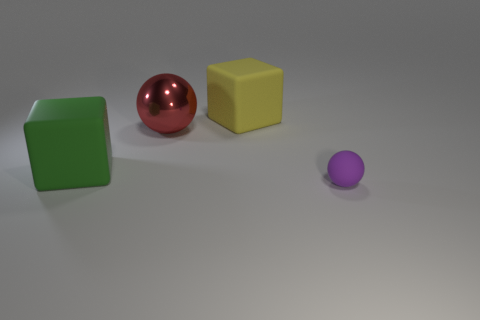Add 3 big things. How many objects exist? 7 Subtract 0 cyan balls. How many objects are left? 4 Subtract all yellow objects. Subtract all large green objects. How many objects are left? 2 Add 4 red objects. How many red objects are left? 5 Add 2 large red balls. How many large red balls exist? 3 